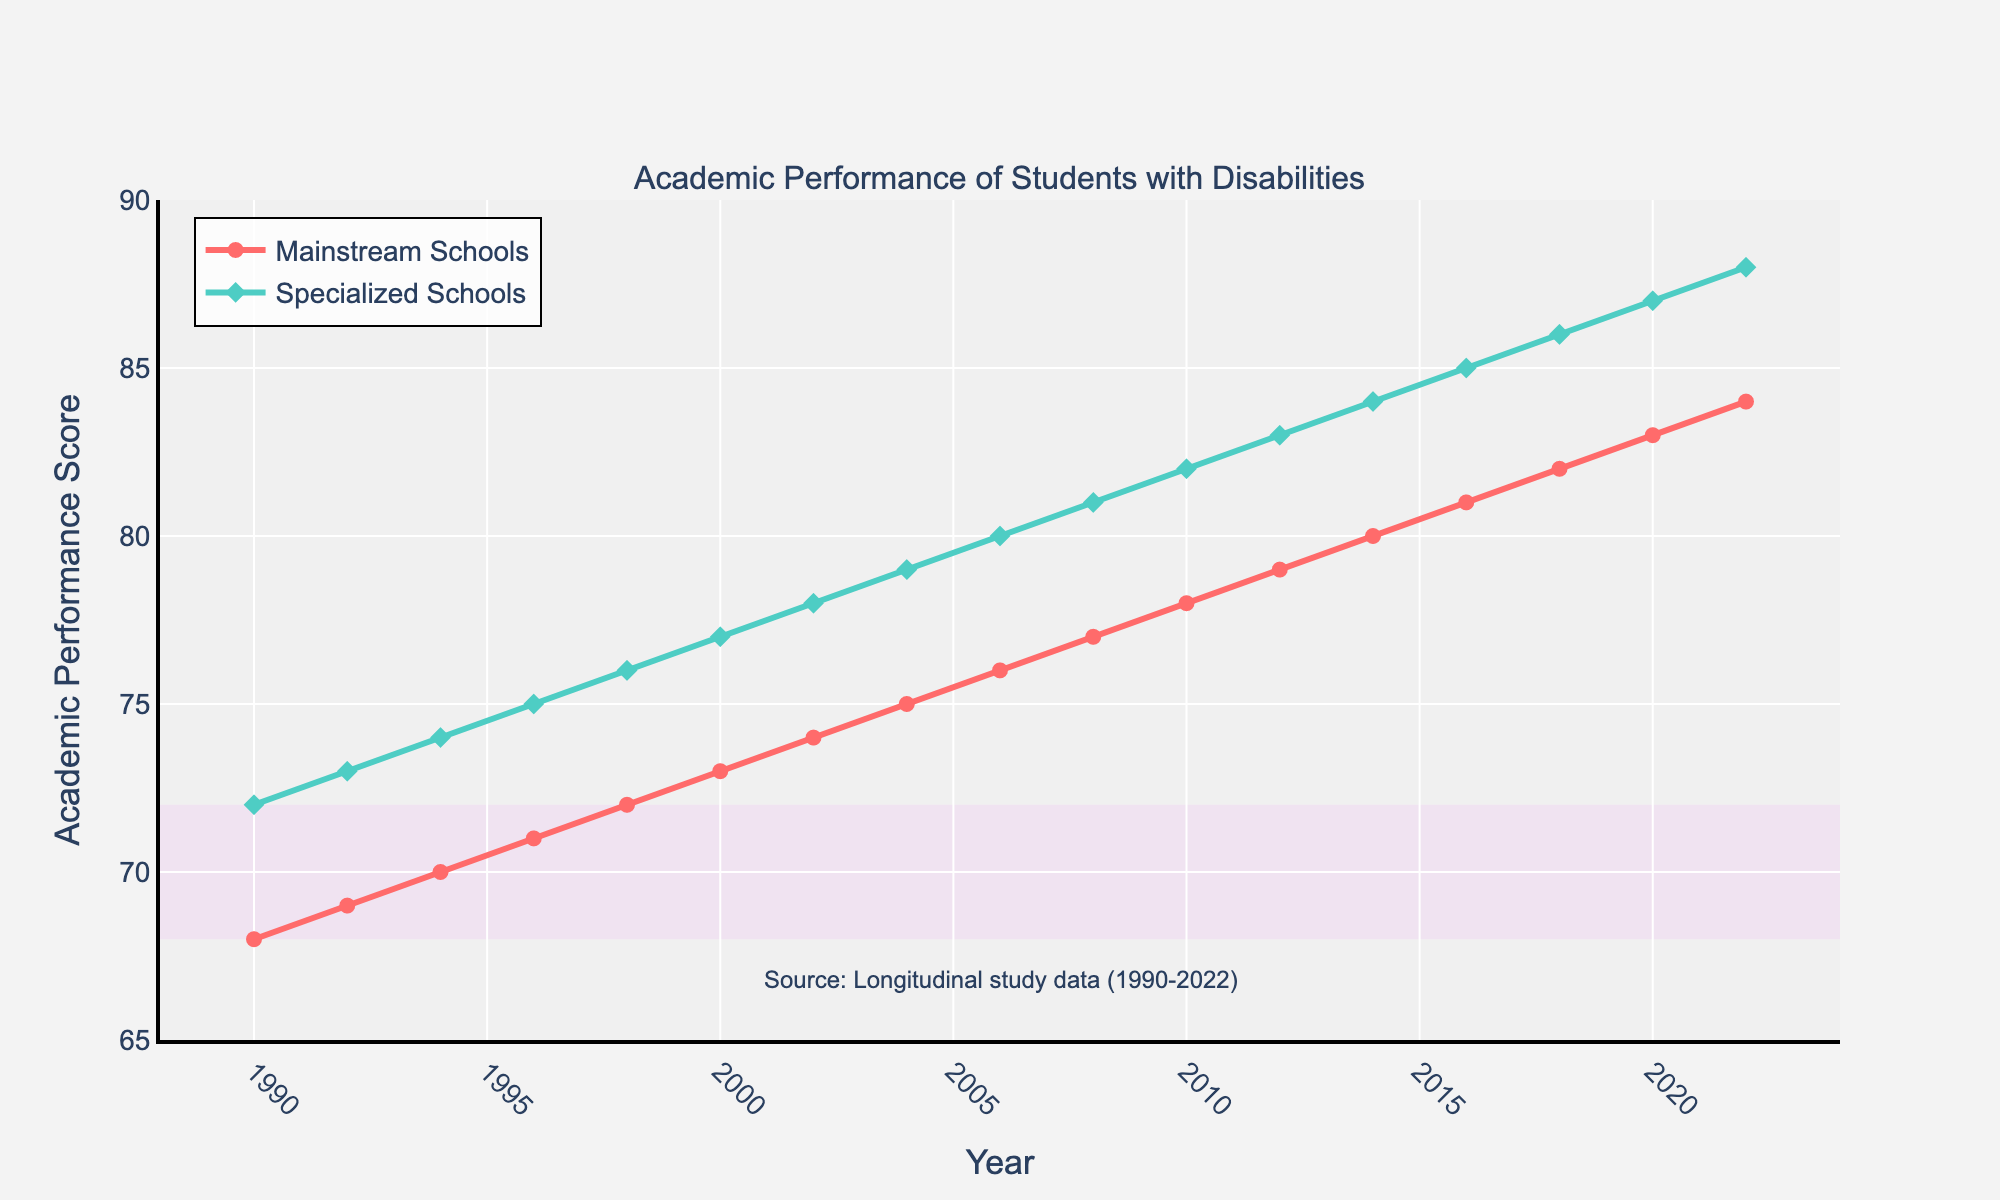What is the academic performance difference between mainstream and specialized schools in 2022? Look at the value of the academic performance score for each type of school in 2022. Mainstream Schools score is 84, and Specialized Schools score is 88. The difference is 88 - 84.
Answer: 4 Which type of school consistently shows higher performance scores over the studied period? From 1990 to 2022, the line representing Specialized Schools is consistently above the line representing Mainstream Schools. This indicates higher performance scores in Specialized Schools throughout the period.
Answer: Specialized Schools What is the average academic performance score for specialized schools in the provided data? Add all the scores for Specialized Schools from 1990 to 2022 and divide by the number of data points. (72 + 73 + 74 + 75 + 76 + 77 + 78 + 79 + 80 + 81 + 82 + 83 + 84 + 85 + 86 + 87 + 88) / 17.
Answer: 80 Which year shows the highest increase in academic performance for mainstream schools compared to the previous year? Calculate the increase in scores for each year compared to the previous year. The highest increase is found between 2016 and 2018, where the score increased from 81 to 82.
Answer: 2018 How do the performance scores in mainstream schools change from 1990 to 2022? Check the scores for mainstream schools in 1990 and 2022. In 1990, the score is 68 and in 2022, it is 84. This shows an overall increase.
Answer: Increase What is the average performance difference between specialized and mainstream schools over the period? Calculate the differences for each pair of scores from 1990 to 2022 and then find the average value: [(72-68) + (73-69) + (74-70) + (75-71) + (76-72) + (77-73) + (78-74) + (79-75) + (80-76) + (81-77) + (82-78) + (83-79) + (84-80) + (85-81) + (86-82) + (87-83) + (88-84)] / 17
Answer: 4 During which years is the gap between mainstream and specialized schools the smallest? Compare the gaps between the two types of schools for each year. The smallest gap is found in the initial years.
Answer: 1990 What percentage did the academic performance score in mainstream schools increase from 1990 to 2022? Calculate the percentage increase: ((84 - 68) / 68) * 100%.
Answer: 23.53% How many years did it take for specialized schools to go from a score of 72 to 85? Find the years in which these scores occurred. Specialized Schools had a score of 72 in 1990, and 85 in 2016. The number of years between 1990 and 2016 is 26.
Answer: 26 